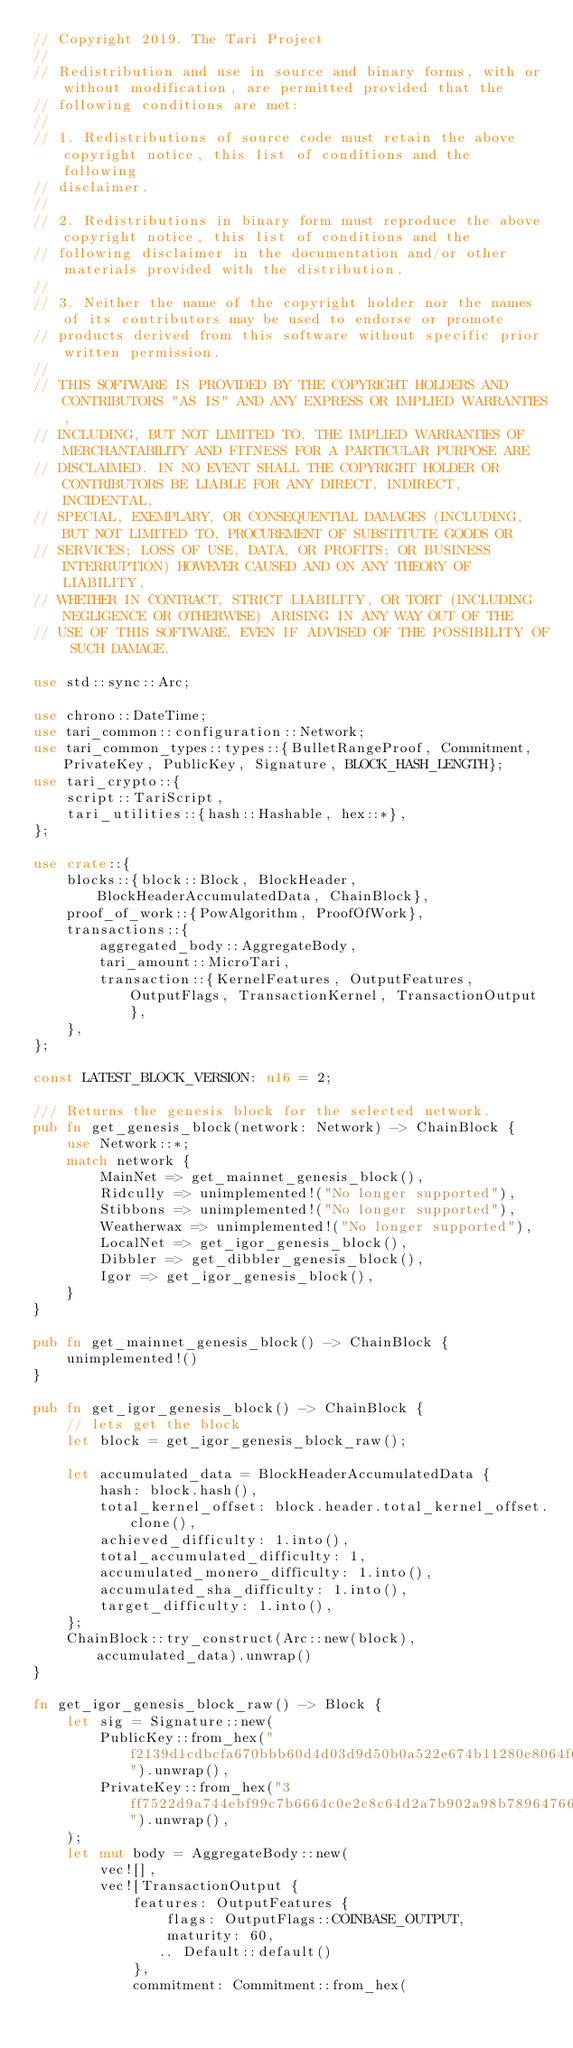<code> <loc_0><loc_0><loc_500><loc_500><_Rust_>// Copyright 2019. The Tari Project
//
// Redistribution and use in source and binary forms, with or without modification, are permitted provided that the
// following conditions are met:
//
// 1. Redistributions of source code must retain the above copyright notice, this list of conditions and the following
// disclaimer.
//
// 2. Redistributions in binary form must reproduce the above copyright notice, this list of conditions and the
// following disclaimer in the documentation and/or other materials provided with the distribution.
//
// 3. Neither the name of the copyright holder nor the names of its contributors may be used to endorse or promote
// products derived from this software without specific prior written permission.
//
// THIS SOFTWARE IS PROVIDED BY THE COPYRIGHT HOLDERS AND CONTRIBUTORS "AS IS" AND ANY EXPRESS OR IMPLIED WARRANTIES,
// INCLUDING, BUT NOT LIMITED TO, THE IMPLIED WARRANTIES OF MERCHANTABILITY AND FITNESS FOR A PARTICULAR PURPOSE ARE
// DISCLAIMED. IN NO EVENT SHALL THE COPYRIGHT HOLDER OR CONTRIBUTORS BE LIABLE FOR ANY DIRECT, INDIRECT, INCIDENTAL,
// SPECIAL, EXEMPLARY, OR CONSEQUENTIAL DAMAGES (INCLUDING, BUT NOT LIMITED TO, PROCUREMENT OF SUBSTITUTE GOODS OR
// SERVICES; LOSS OF USE, DATA, OR PROFITS; OR BUSINESS INTERRUPTION) HOWEVER CAUSED AND ON ANY THEORY OF LIABILITY,
// WHETHER IN CONTRACT, STRICT LIABILITY, OR TORT (INCLUDING NEGLIGENCE OR OTHERWISE) ARISING IN ANY WAY OUT OF THE
// USE OF THIS SOFTWARE, EVEN IF ADVISED OF THE POSSIBILITY OF SUCH DAMAGE.

use std::sync::Arc;

use chrono::DateTime;
use tari_common::configuration::Network;
use tari_common_types::types::{BulletRangeProof, Commitment, PrivateKey, PublicKey, Signature, BLOCK_HASH_LENGTH};
use tari_crypto::{
    script::TariScript,
    tari_utilities::{hash::Hashable, hex::*},
};

use crate::{
    blocks::{block::Block, BlockHeader, BlockHeaderAccumulatedData, ChainBlock},
    proof_of_work::{PowAlgorithm, ProofOfWork},
    transactions::{
        aggregated_body::AggregateBody,
        tari_amount::MicroTari,
        transaction::{KernelFeatures, OutputFeatures, OutputFlags, TransactionKernel, TransactionOutput},
    },
};

const LATEST_BLOCK_VERSION: u16 = 2;

/// Returns the genesis block for the selected network.
pub fn get_genesis_block(network: Network) -> ChainBlock {
    use Network::*;
    match network {
        MainNet => get_mainnet_genesis_block(),
        Ridcully => unimplemented!("No longer supported"),
        Stibbons => unimplemented!("No longer supported"),
        Weatherwax => unimplemented!("No longer supported"),
        LocalNet => get_igor_genesis_block(),
        Dibbler => get_dibbler_genesis_block(),
        Igor => get_igor_genesis_block(),
    }
}

pub fn get_mainnet_genesis_block() -> ChainBlock {
    unimplemented!()
}

pub fn get_igor_genesis_block() -> ChainBlock {
    // lets get the block
    let block = get_igor_genesis_block_raw();

    let accumulated_data = BlockHeaderAccumulatedData {
        hash: block.hash(),
        total_kernel_offset: block.header.total_kernel_offset.clone(),
        achieved_difficulty: 1.into(),
        total_accumulated_difficulty: 1,
        accumulated_monero_difficulty: 1.into(),
        accumulated_sha_difficulty: 1.into(),
        target_difficulty: 1.into(),
    };
    ChainBlock::try_construct(Arc::new(block), accumulated_data).unwrap()
}

fn get_igor_genesis_block_raw() -> Block {
    let sig = Signature::new(
        PublicKey::from_hex("f2139d1cdbcfa670bbb60d4d03d9d50b0a522e674b11280e8064f6dc30e84133").unwrap(),
        PrivateKey::from_hex("3ff7522d9a744ebf99c7b6664c0e2c8c64d2a7b902a98b78964766f9f7f2b107").unwrap(),
    );
    let mut body = AggregateBody::new(
        vec![],
        vec![TransactionOutput {
            features: OutputFeatures {
                flags: OutputFlags::COINBASE_OUTPUT,
                maturity: 60,
               .. Default::default()
            },
            commitment: Commitment::from_hex(</code> 